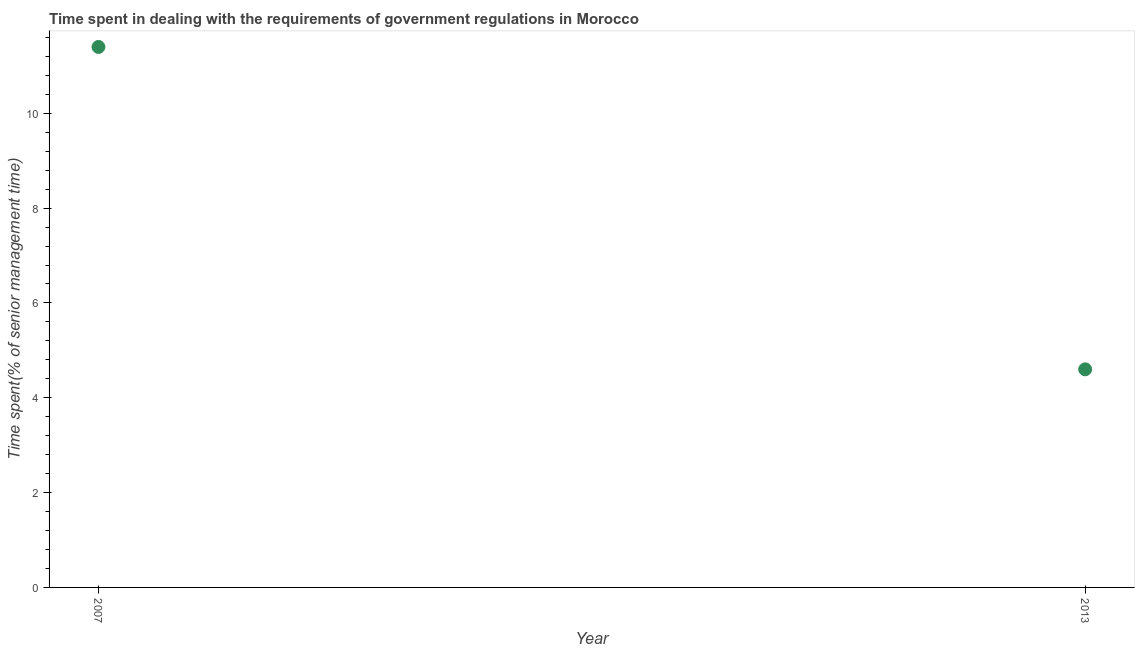Across all years, what is the maximum time spent in dealing with government regulations?
Keep it short and to the point. 11.4. In which year was the time spent in dealing with government regulations minimum?
Your answer should be very brief. 2013. What is the sum of the time spent in dealing with government regulations?
Keep it short and to the point. 16. What is the difference between the time spent in dealing with government regulations in 2007 and 2013?
Provide a succinct answer. 6.8. What is the average time spent in dealing with government regulations per year?
Your response must be concise. 8. What is the median time spent in dealing with government regulations?
Offer a terse response. 8. Do a majority of the years between 2013 and 2007 (inclusive) have time spent in dealing with government regulations greater than 0.8 %?
Make the answer very short. No. What is the ratio of the time spent in dealing with government regulations in 2007 to that in 2013?
Provide a succinct answer. 2.48. Is the time spent in dealing with government regulations in 2007 less than that in 2013?
Your answer should be compact. No. How many dotlines are there?
Provide a short and direct response. 1. How many years are there in the graph?
Provide a succinct answer. 2. What is the difference between two consecutive major ticks on the Y-axis?
Offer a very short reply. 2. Does the graph contain any zero values?
Offer a very short reply. No. Does the graph contain grids?
Provide a short and direct response. No. What is the title of the graph?
Ensure brevity in your answer.  Time spent in dealing with the requirements of government regulations in Morocco. What is the label or title of the X-axis?
Ensure brevity in your answer.  Year. What is the label or title of the Y-axis?
Your answer should be compact. Time spent(% of senior management time). What is the Time spent(% of senior management time) in 2007?
Give a very brief answer. 11.4. What is the Time spent(% of senior management time) in 2013?
Give a very brief answer. 4.6. What is the difference between the Time spent(% of senior management time) in 2007 and 2013?
Keep it short and to the point. 6.8. What is the ratio of the Time spent(% of senior management time) in 2007 to that in 2013?
Your answer should be very brief. 2.48. 